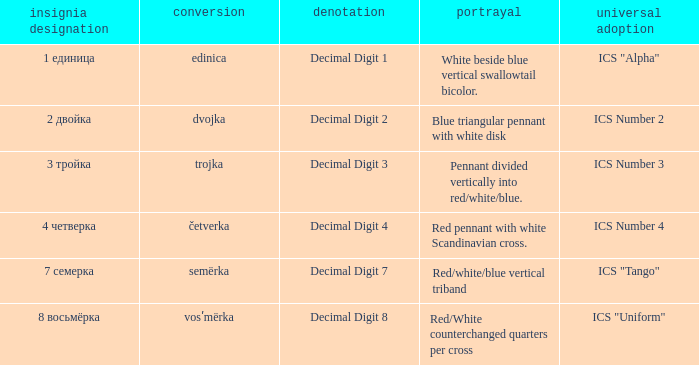What are the meanings of the flag whose name transliterates to semërka? Decimal Digit 7. 